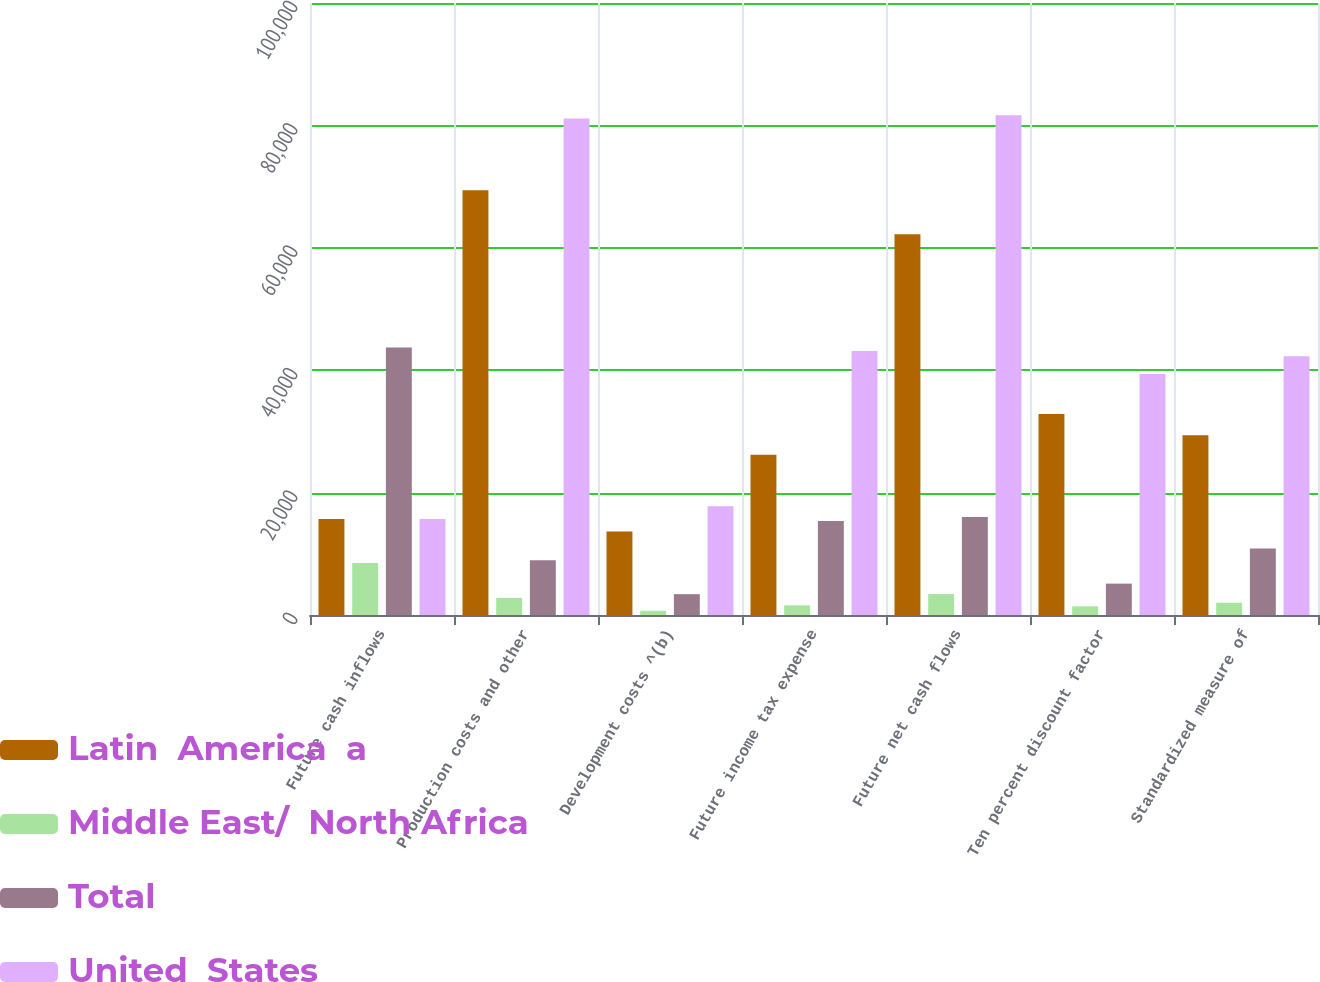Convert chart to OTSL. <chart><loc_0><loc_0><loc_500><loc_500><stacked_bar_chart><ecel><fcel>Future cash inflows<fcel>Production costs and other<fcel>Development costs ^(b)<fcel>Future income tax expense<fcel>Future net cash flows<fcel>Ten percent discount factor<fcel>Standardized measure of<nl><fcel>Latin  America  a<fcel>15691<fcel>69404<fcel>13660<fcel>26175<fcel>62217<fcel>32835<fcel>29382<nl><fcel>Middle East/  North Africa<fcel>8494<fcel>2807<fcel>689<fcel>1579<fcel>3419<fcel>1415<fcel>2004<nl><fcel>Total<fcel>43715<fcel>8926<fcel>3407<fcel>15374<fcel>16008<fcel>5127<fcel>10881<nl><fcel>United  States<fcel>15691<fcel>81137<fcel>17756<fcel>43128<fcel>81644<fcel>39377<fcel>42267<nl></chart> 